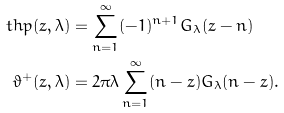Convert formula to latex. <formula><loc_0><loc_0><loc_500><loc_500>\ t h p ( z , \lambda ) & = \sum _ { n = 1 } ^ { \infty } ( - 1 ) ^ { n + 1 } G _ { \lambda } ( z - n ) \\ \vartheta ^ { + } ( z , \lambda ) & = 2 \pi \lambda \sum _ { n = 1 } ^ { \infty } ( n - z ) G _ { \lambda } ( n - z ) .</formula> 